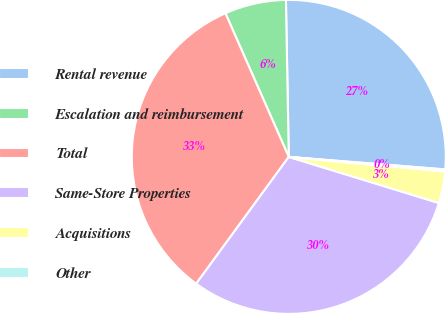<chart> <loc_0><loc_0><loc_500><loc_500><pie_chart><fcel>Rental revenue<fcel>Escalation and reimbursement<fcel>Total<fcel>Same-Store Properties<fcel>Acquisitions<fcel>Other<nl><fcel>26.56%<fcel>6.32%<fcel>33.35%<fcel>30.29%<fcel>3.26%<fcel>0.21%<nl></chart> 